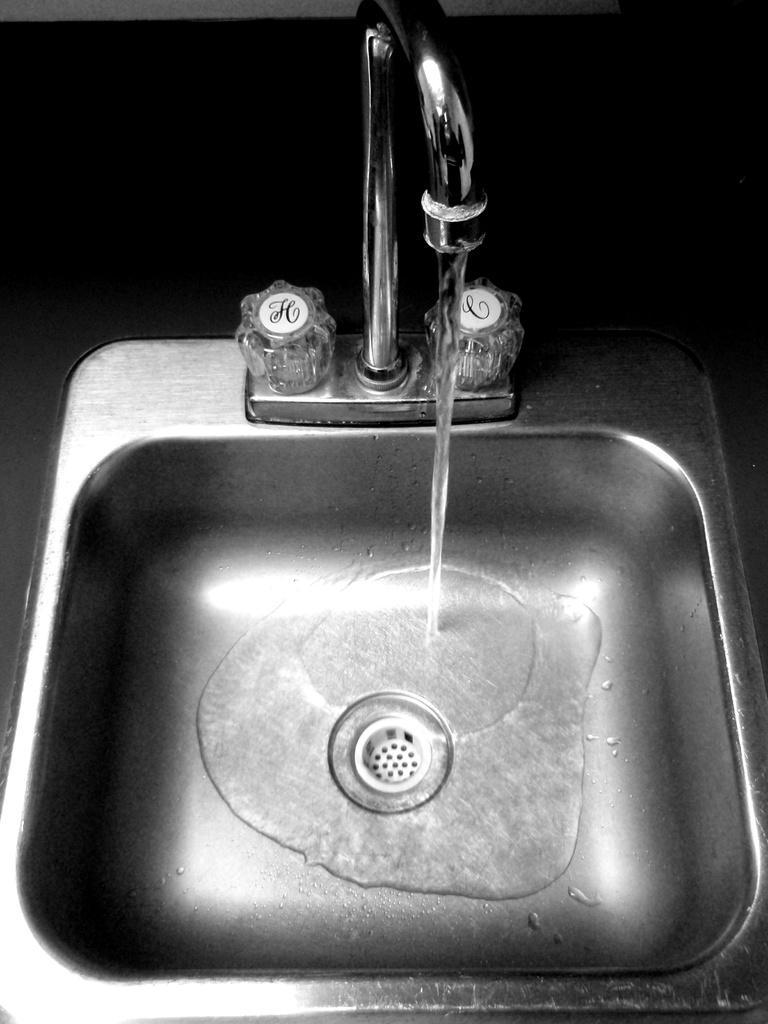Could you give a brief overview of what you see in this image? In this image there is water flowing through the tap in the sink. 